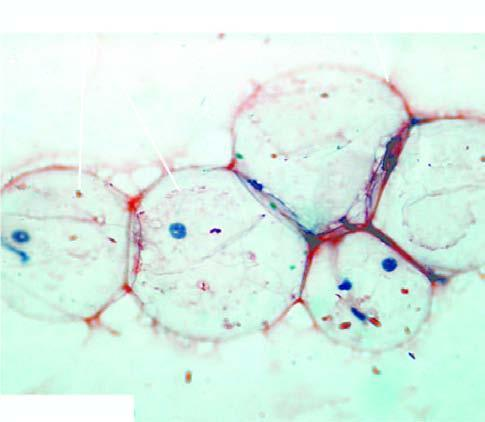s section from margin of amoebic ulcer stain for amyloid?
Answer the question using a single word or phrase. No 